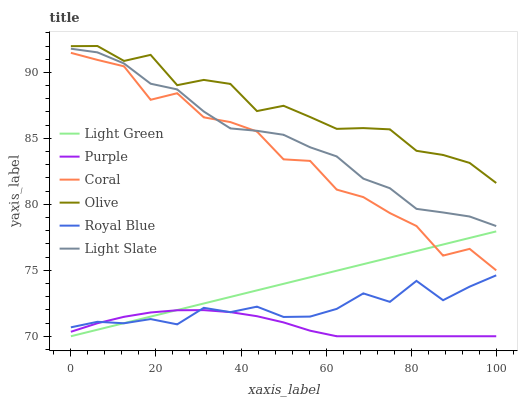Does Purple have the minimum area under the curve?
Answer yes or no. Yes. Does Olive have the maximum area under the curve?
Answer yes or no. Yes. Does Coral have the minimum area under the curve?
Answer yes or no. No. Does Coral have the maximum area under the curve?
Answer yes or no. No. Is Light Green the smoothest?
Answer yes or no. Yes. Is Coral the roughest?
Answer yes or no. Yes. Is Purple the smoothest?
Answer yes or no. No. Is Purple the roughest?
Answer yes or no. No. Does Purple have the lowest value?
Answer yes or no. Yes. Does Coral have the lowest value?
Answer yes or no. No. Does Olive have the highest value?
Answer yes or no. Yes. Does Coral have the highest value?
Answer yes or no. No. Is Light Green less than Light Slate?
Answer yes or no. Yes. Is Olive greater than Light Green?
Answer yes or no. Yes. Does Purple intersect Royal Blue?
Answer yes or no. Yes. Is Purple less than Royal Blue?
Answer yes or no. No. Is Purple greater than Royal Blue?
Answer yes or no. No. Does Light Green intersect Light Slate?
Answer yes or no. No. 